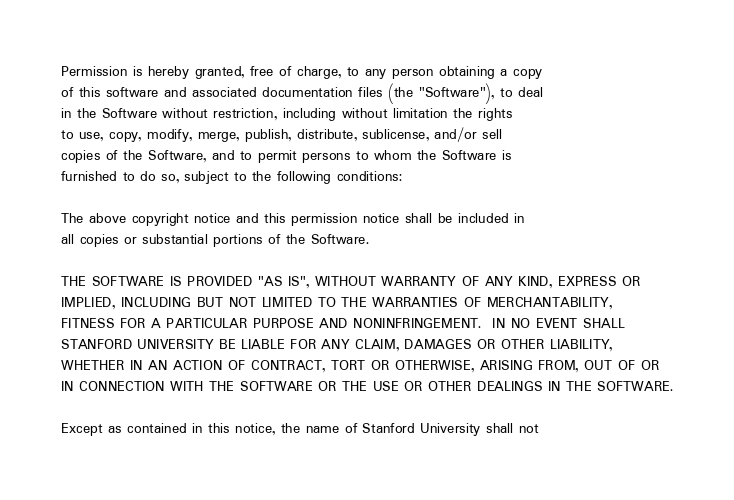<code> <loc_0><loc_0><loc_500><loc_500><_HTML_>Permission is hereby granted, free of charge, to any person obtaining a copy
of this software and associated documentation files (the "Software"), to deal
in the Software without restriction, including without limitation the rights
to use, copy, modify, merge, publish, distribute, sublicense, and/or sell
copies of the Software, and to permit persons to whom the Software is
furnished to do so, subject to the following conditions:

The above copyright notice and this permission notice shall be included in
all copies or substantial portions of the Software.

THE SOFTWARE IS PROVIDED "AS IS", WITHOUT WARRANTY OF ANY KIND, EXPRESS OR
IMPLIED, INCLUDING BUT NOT LIMITED TO THE WARRANTIES OF MERCHANTABILITY,
FITNESS FOR A PARTICULAR PURPOSE AND NONINFRINGEMENT.  IN NO EVENT SHALL
STANFORD UNIVERSITY BE LIABLE FOR ANY CLAIM, DAMAGES OR OTHER LIABILITY,
WHETHER IN AN ACTION OF CONTRACT, TORT OR OTHERWISE, ARISING FROM, OUT OF OR
IN CONNECTION WITH THE SOFTWARE OR THE USE OR OTHER DEALINGS IN THE SOFTWARE.

Except as contained in this notice, the name of Stanford University shall not</code> 